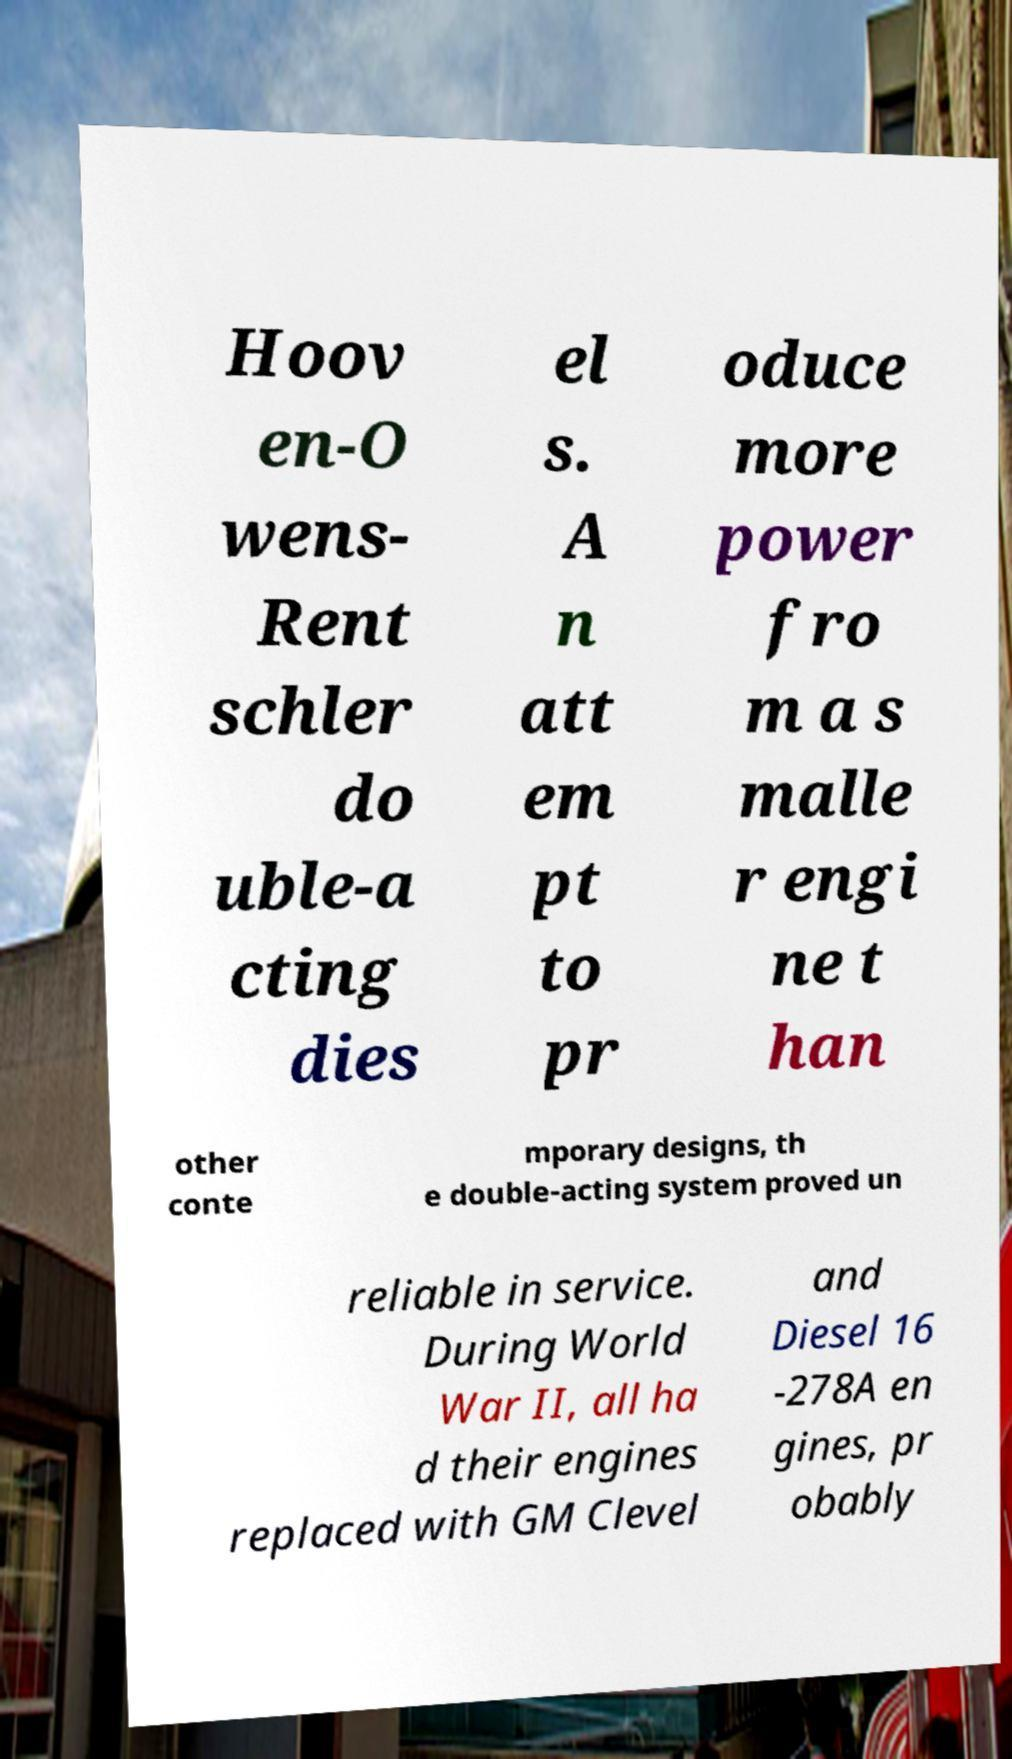For documentation purposes, I need the text within this image transcribed. Could you provide that? Hoov en-O wens- Rent schler do uble-a cting dies el s. A n att em pt to pr oduce more power fro m a s malle r engi ne t han other conte mporary designs, th e double-acting system proved un reliable in service. During World War II, all ha d their engines replaced with GM Clevel and Diesel 16 -278A en gines, pr obably 